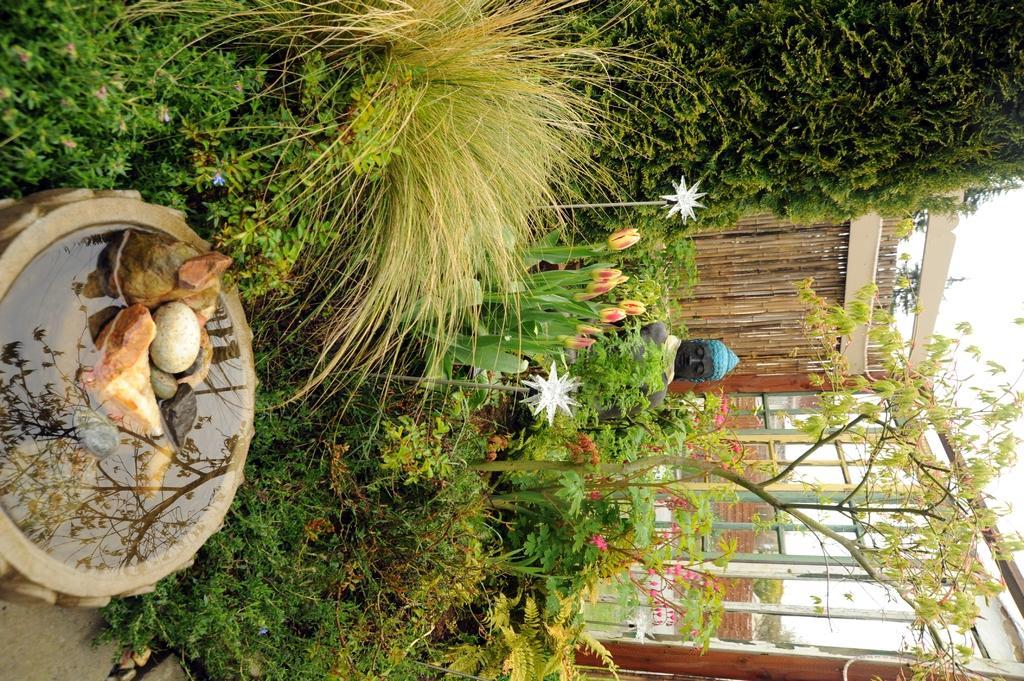How would you summarize this image in a sentence or two? In this rotated image there are plants and tree. To the left there is a bowl. There are pebbles and water in the bowl. In the center there is a sculpture of Gautama Buddha. There are plants in front of the sculpture. There are flowers to the plants. Behind him there is a wooden wall. To the right there is the sky. 